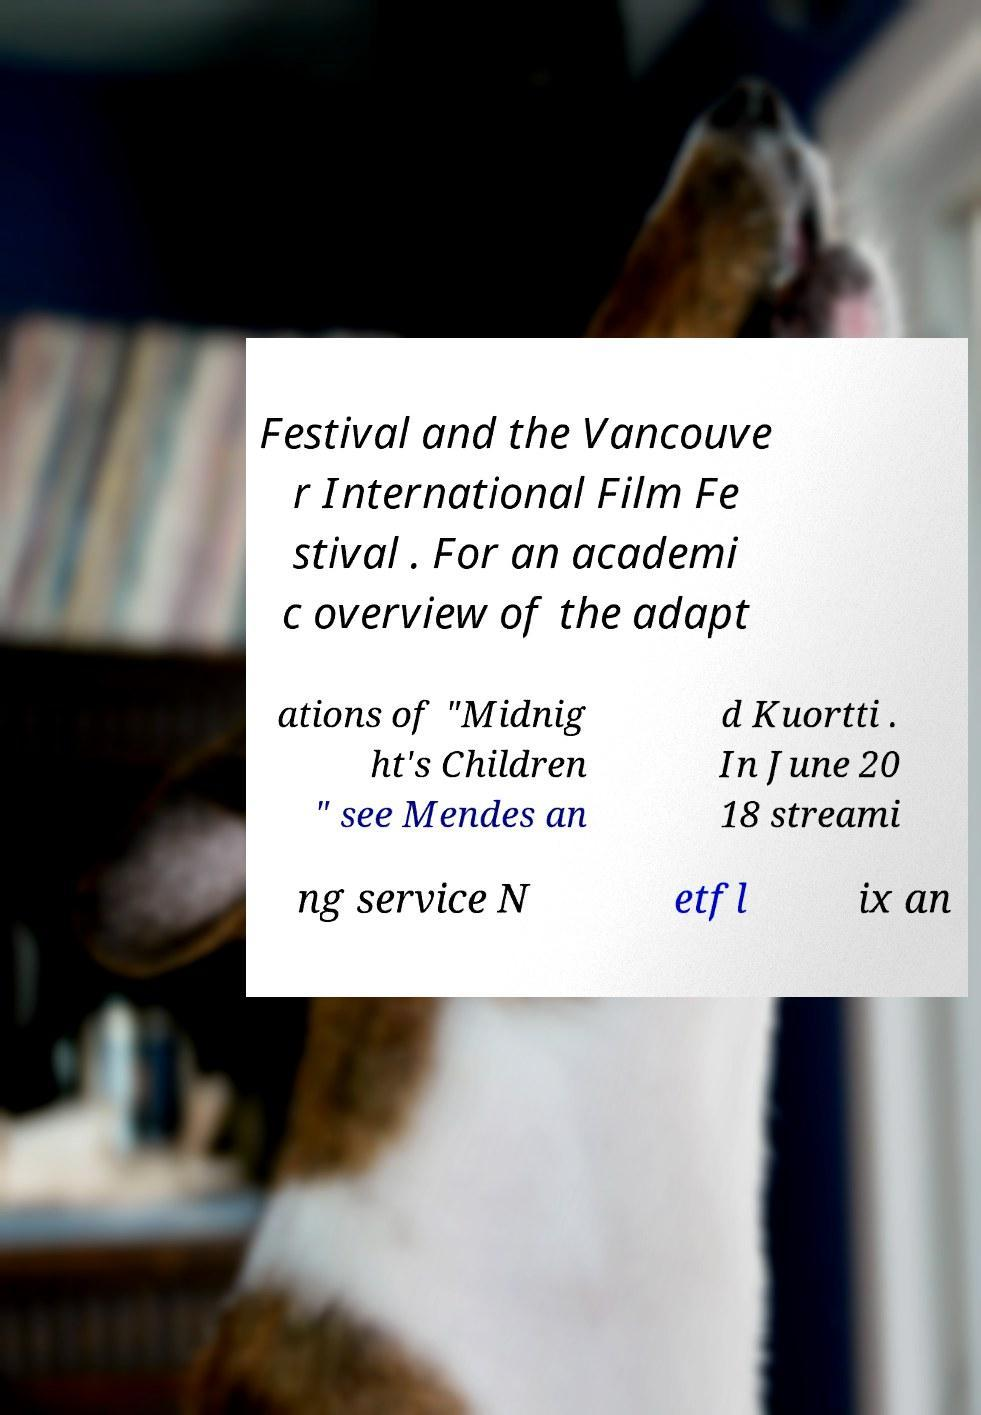Could you assist in decoding the text presented in this image and type it out clearly? Festival and the Vancouve r International Film Fe stival . For an academi c overview of the adapt ations of "Midnig ht's Children " see Mendes an d Kuortti . In June 20 18 streami ng service N etfl ix an 